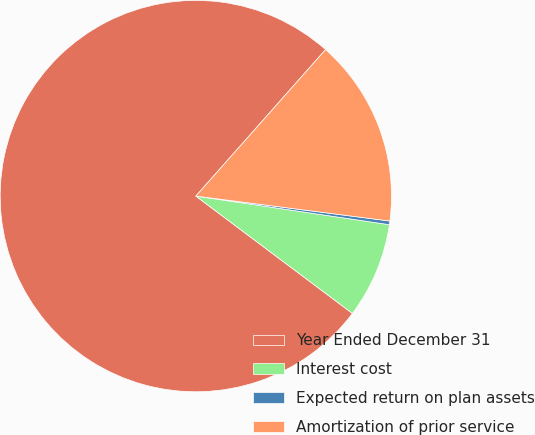Convert chart. <chart><loc_0><loc_0><loc_500><loc_500><pie_chart><fcel>Year Ended December 31<fcel>Interest cost<fcel>Expected return on plan assets<fcel>Amortization of prior service<nl><fcel>76.29%<fcel>7.9%<fcel>0.3%<fcel>15.5%<nl></chart> 